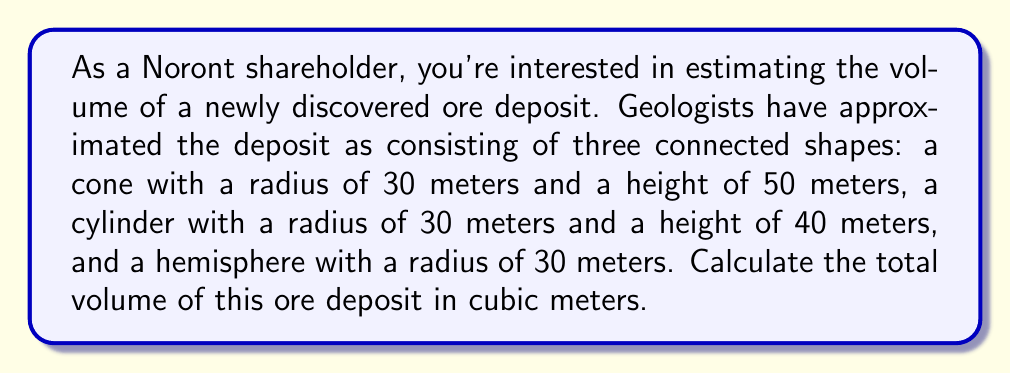Can you answer this question? Let's break this down step-by-step:

1. Volume of the cone:
   The formula for the volume of a cone is $V_c = \frac{1}{3}\pi r^2 h$
   $$V_c = \frac{1}{3} \pi (30\text{ m})^2 (50\text{ m}) = \frac{1}{3} \pi (900) (50) = 15,000\pi \text{ m}^3$$

2. Volume of the cylinder:
   The formula for the volume of a cylinder is $V_{cyl} = \pi r^2 h$
   $$V_{cyl} = \pi (30\text{ m})^2 (40\text{ m}) = \pi (900) (40) = 36,000\pi \text{ m}^3$$

3. Volume of the hemisphere:
   The formula for the volume of a hemisphere is $V_h = \frac{2}{3}\pi r^3$
   $$V_h = \frac{2}{3} \pi (30\text{ m})^3 = \frac{2}{3} \pi (27,000) = 18,000\pi \text{ m}^3$$

4. Total volume:
   Sum the volumes of all three shapes
   $$V_{total} = V_c + V_{cyl} + V_h$$
   $$V_{total} = 15,000\pi + 36,000\pi + 18,000\pi = 69,000\pi \text{ m}^3$$

5. Simplify:
   $$V_{total} = 216,814.2 \text{ m}^3 \approx 216,814 \text{ m}^3 \text{ (rounded to nearest whole number)}$$
Answer: 216,814 m³ 